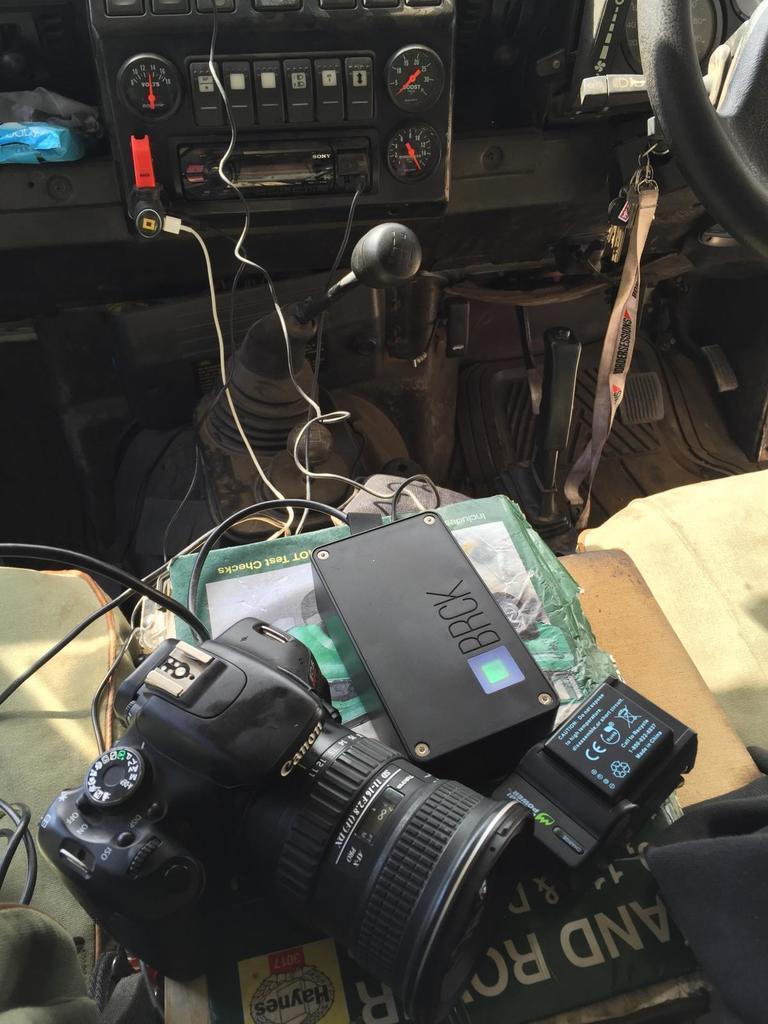Can you describe this image briefly? The image is taken inside the vehicle. There is a camera, battery and an object placed on the seat and we can see wires. 